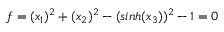Convert formula to latex. <formula><loc_0><loc_0><loc_500><loc_500>f = ( x _ { 1 } ) ^ { 2 } + ( x _ { 2 } ) ^ { 2 } - ( \sinh ( x _ { 3 } ) ) ^ { 2 } - 1 = 0</formula> 